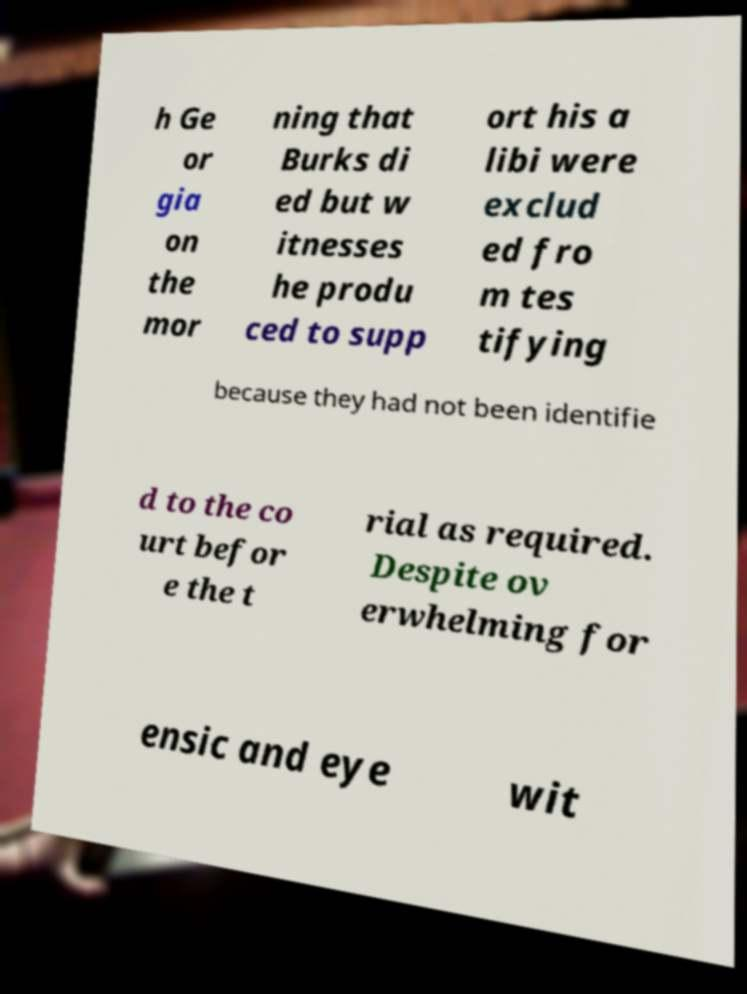I need the written content from this picture converted into text. Can you do that? h Ge or gia on the mor ning that Burks di ed but w itnesses he produ ced to supp ort his a libi were exclud ed fro m tes tifying because they had not been identifie d to the co urt befor e the t rial as required. Despite ov erwhelming for ensic and eye wit 